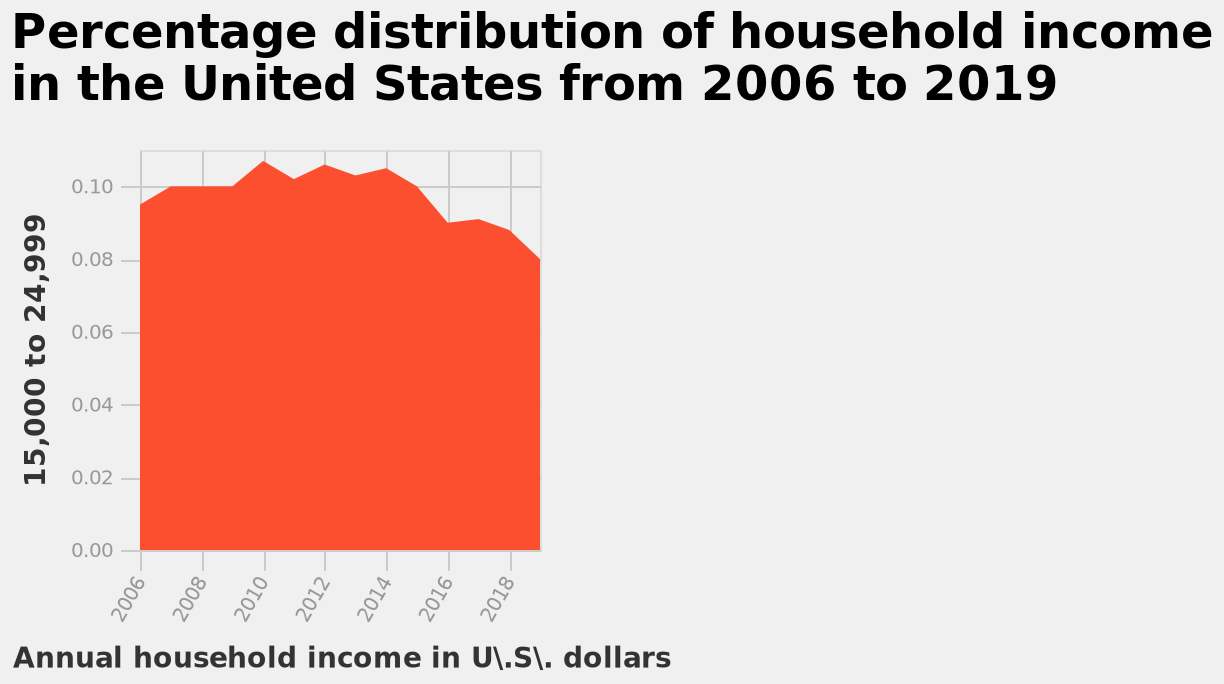<image>
Which country's household income distribution does the plot represent? The plot represents the household income distribution in the United States from 2006 to 2019. What is the type of plot used for the distribution of household income from 2006 to 2019 in the United States?  The type of plot used is an area plot. What can be observed about the distribution of household income based on the given information? Based on the given information, the distribution of household income remained relatively stable between 2010 and 2014, but started to steadily decrease from 2014 onwards. What is the range of the linear scale along the y-axis? The range of the linear scale along the y-axis is from 0.00 to 0.10. Did the distribution of household income remain relatively unstable between 2010 and 2014, but start to steadily increase from 2014 onwards? No.Based on the given information, the distribution of household income remained relatively stable between 2010 and 2014, but started to steadily decrease from 2014 onwards. 